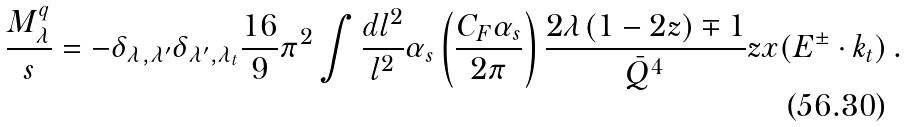Convert formula to latex. <formula><loc_0><loc_0><loc_500><loc_500>\frac { M ^ { q } _ { \lambda } } s = - \delta _ { \lambda , \lambda ^ { \prime } } \delta _ { \lambda ^ { \prime } , \lambda _ { t } } \frac { 1 6 } 9 \pi ^ { 2 } \int \frac { d l ^ { 2 } } { l ^ { 2 } } \alpha _ { s } \left ( \frac { C _ { F } \alpha _ { s } } { 2 \pi } \right ) \frac { 2 \lambda ( 1 - 2 z ) \mp 1 } { \bar { Q } ^ { 4 } } z x ( E ^ { \pm } \cdot k _ { t } ) \, .</formula> 